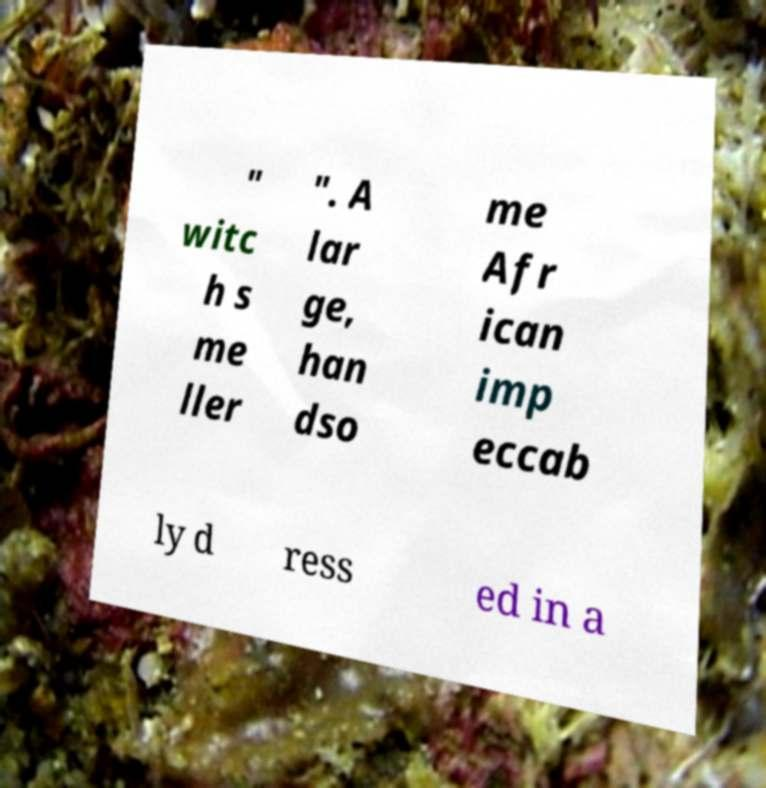What messages or text are displayed in this image? I need them in a readable, typed format. " witc h s me ller ". A lar ge, han dso me Afr ican imp eccab ly d ress ed in a 